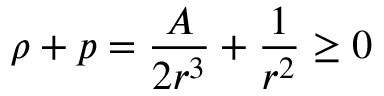<formula> <loc_0><loc_0><loc_500><loc_500>\rho + p = \frac { A } { 2 r ^ { 3 } } + \frac { 1 } { r ^ { 2 } } \geq 0</formula> 